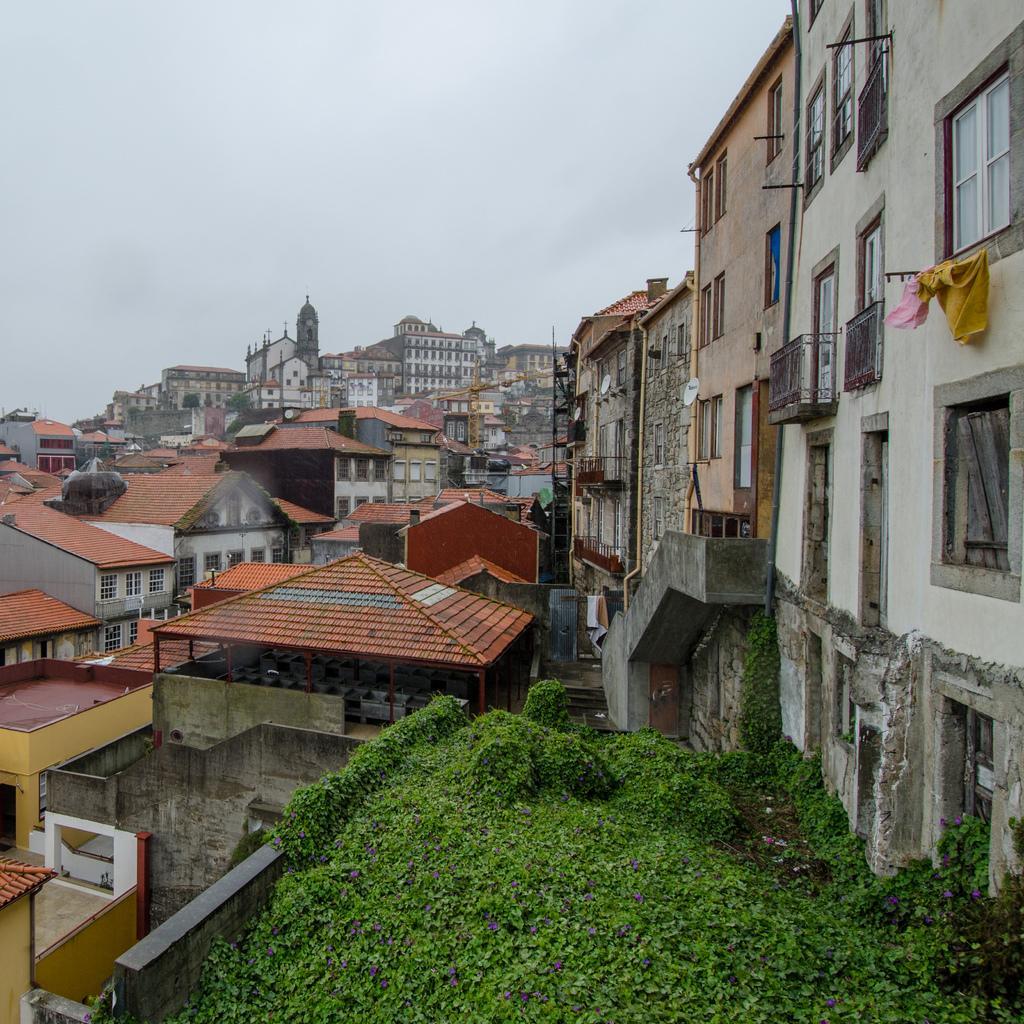Describe this image in one or two sentences. In this picture I can see at the bottom there are plants, in the middle there are buildings, at the top there is the sky. 